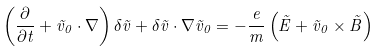Convert formula to latex. <formula><loc_0><loc_0><loc_500><loc_500>\left ( \frac { \partial } { \partial t } + \vec { v } _ { 0 } \cdot \nabla \right ) \delta \vec { v } + \delta \vec { v } \cdot \nabla \vec { v } _ { 0 } = - \frac { e } { m } \left ( \vec { E } + \vec { v } _ { 0 } \times \vec { B } \right )</formula> 